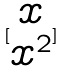<formula> <loc_0><loc_0><loc_500><loc_500>[ \begin{matrix} x \\ x ^ { 2 } \end{matrix} ]</formula> 